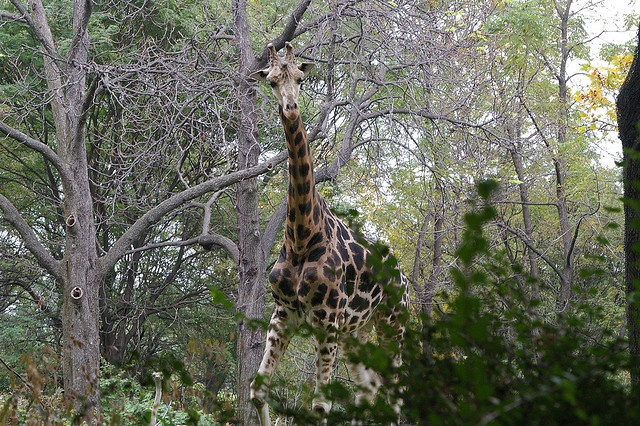Describe the objects in this image and their specific colors. I can see a giraffe in darkgray, black, and gray tones in this image. 